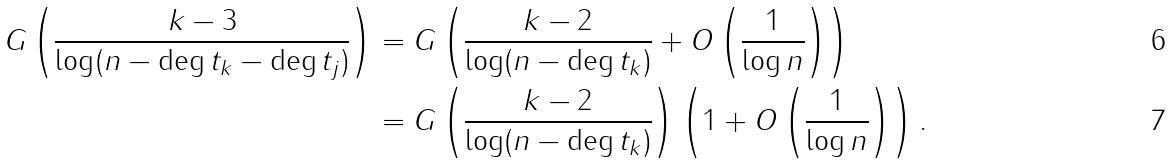Convert formula to latex. <formula><loc_0><loc_0><loc_500><loc_500>G \left ( \frac { k - 3 } { \log ( n - \deg t _ { k } - \deg t _ { j } ) } \right ) & = G \left ( \frac { k - 2 } { \log ( n - \deg t _ { k } ) } + O \left ( \frac { 1 } { \log n } \right ) \right ) \\ & = G \left ( \frac { k - 2 } { \log ( n - \deg t _ { k } ) } \right ) \left ( 1 + O \left ( \frac { 1 } { \log n } \right ) \right ) .</formula> 